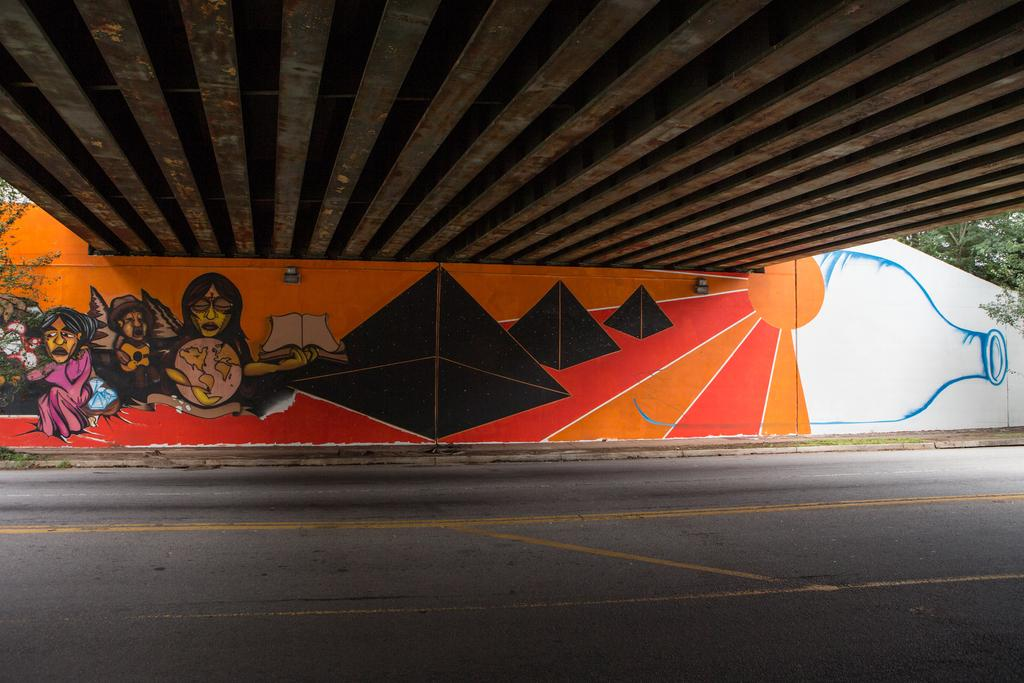What type of structure can be seen in the image? There is a bridge in the image. What natural elements are present in the image? There are trees in the image. What type of artwork is visible in the image? There are paintings on the wall in the image. What type of pathway is at the bottom of the image? There is a road at the bottom of the image. How many chickens are crossing the bridge in the image? There are no chickens present in the image. What season is depicted in the image? The provided facts do not mention any specific season, so it cannot be determined from the image. 